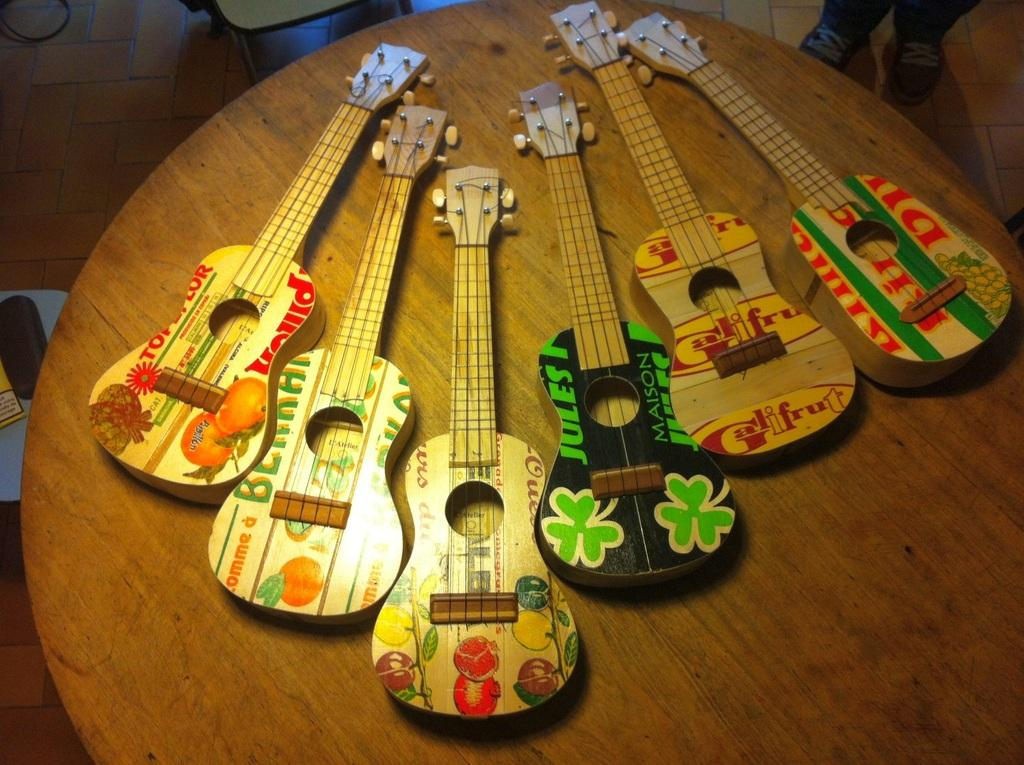What type of table is in the image? There is a circular table in the image. What objects are placed on the table? Six guitars are placed on the table. Can you describe the person standing beside the table? There is a man standing beside the table. What can be seen on the floor in the image? The floor is visible in the image, and tiles are present on the floor. What type of crayon is the man using to write his name on the substance in the image? There is no crayon, name, or substance present in the image. 